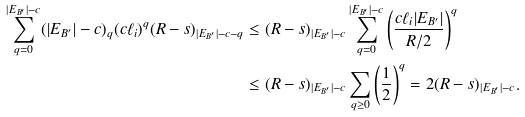<formula> <loc_0><loc_0><loc_500><loc_500>\sum _ { q = 0 } ^ { | E _ { B ^ { \prime } } | - c } ( | E _ { B ^ { \prime } } | - c ) _ { q } ( c \ell _ { i } ) ^ { q } ( R - s ) _ { | E _ { B ^ { \prime } } | - c - q } & \leq ( R - s ) _ { | E _ { B ^ { \prime } } | - c } \sum _ { q = 0 } ^ { | E _ { B ^ { \prime } } | - c } \left ( \frac { c \ell _ { i } | E _ { B ^ { \prime } } | } { R / 2 } \right ) ^ { q } \\ & \leq ( R - s ) _ { | E _ { B ^ { \prime } } | - c } \sum _ { q \geq 0 } \left ( \frac { 1 } { 2 } \right ) ^ { q } = 2 ( R - s ) _ { | E _ { B ^ { \prime } } | - c } .</formula> 